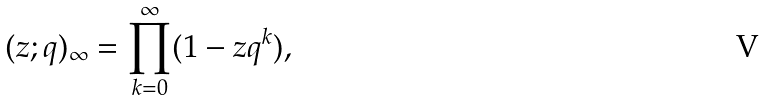Convert formula to latex. <formula><loc_0><loc_0><loc_500><loc_500>( z ; q ) _ { \infty } & = \prod _ { k = 0 } ^ { \infty } ( 1 - z q ^ { k } ) ,</formula> 